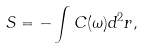Convert formula to latex. <formula><loc_0><loc_0><loc_500><loc_500>S = - \int C ( \omega ) d ^ { 2 } { r } ,</formula> 